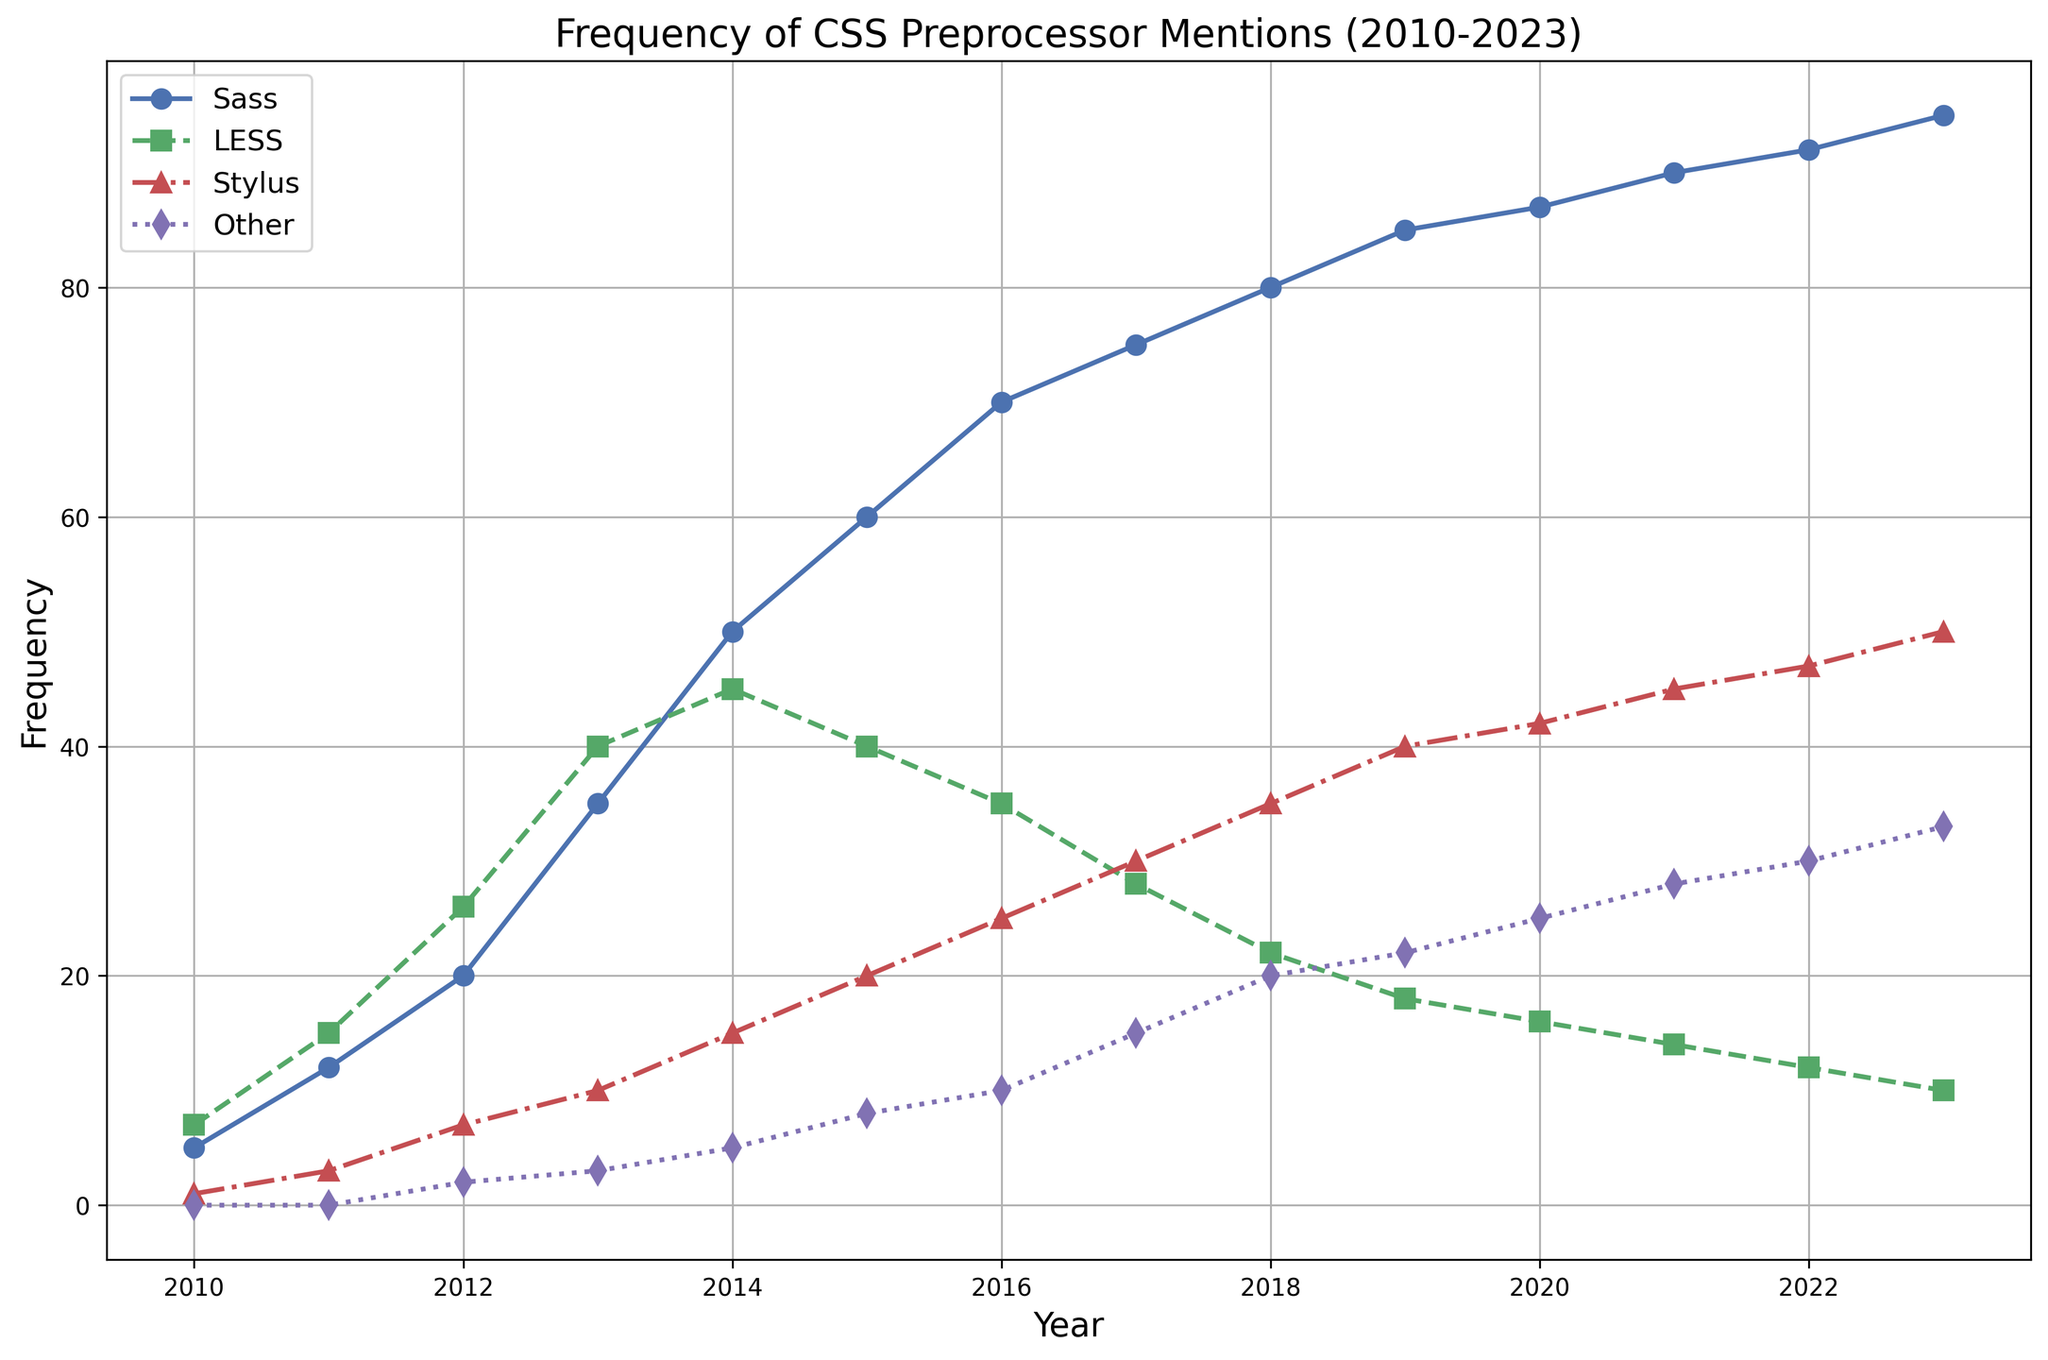What year did Sass surpass LESS in mentions? In 2014, Sass had 50 mentions compared to LESS's 45 mentions.
Answer: 2014 How many mentions did Stylus have in 2023? The chart shows that Stylus had 50 mentions in 2023.
Answer: 50 Which preprocessor had the most mentions in 2015? In 2015, Sass had the most mentions with 60, compared to 40 for LESS, 20 for Stylus, and 8 for Others.
Answer: Sass In which year did "Other" preprocessors first get mentioned? "Other" preprocessors were first mentioned in 2012 with 2 mentions.
Answer: 2012 What was the trend of LESS mentions from 2010 to 2013? LESS mentions increased each year from 7 in 2010 to 40 in 2013.
Answer: Increasing What is the total number of mentions for all preprocessors in 2020? Adding up the mentions in 2020: Sass (87), LESS (16), Stylus (42), Other (25) gives a total of 87+16+42+25 = 170.
Answer: 170 Which preprocessor had the highest growth rate from 2010 to 2023? Sass grew from 5 mentions in 2010 to 95 mentions in 2023, showing the highest increase of 90 among all preprocessors.
Answer: Sass Compare the mentions of Stylus in 2012 and 2022. By how much did it increase? Stylus had 7 mentions in 2012 and 47 mentions in 2022, which is an increase of 47 - 7 = 40 mentions.
Answer: 40 In which year did Sass experience its largest increase in mentions? Sass saw its largest increase from 20 mentions in 2012 to 35 mentions in 2013, an increase of 15.
Answer: 2013 What is the overall trend of 'Other' preprocessor mentions from 2010 to 2023? 'Other' preprocessors showed a consistent upward trend, starting from 0 in 2010 to 33 in 2023.
Answer: Upward 